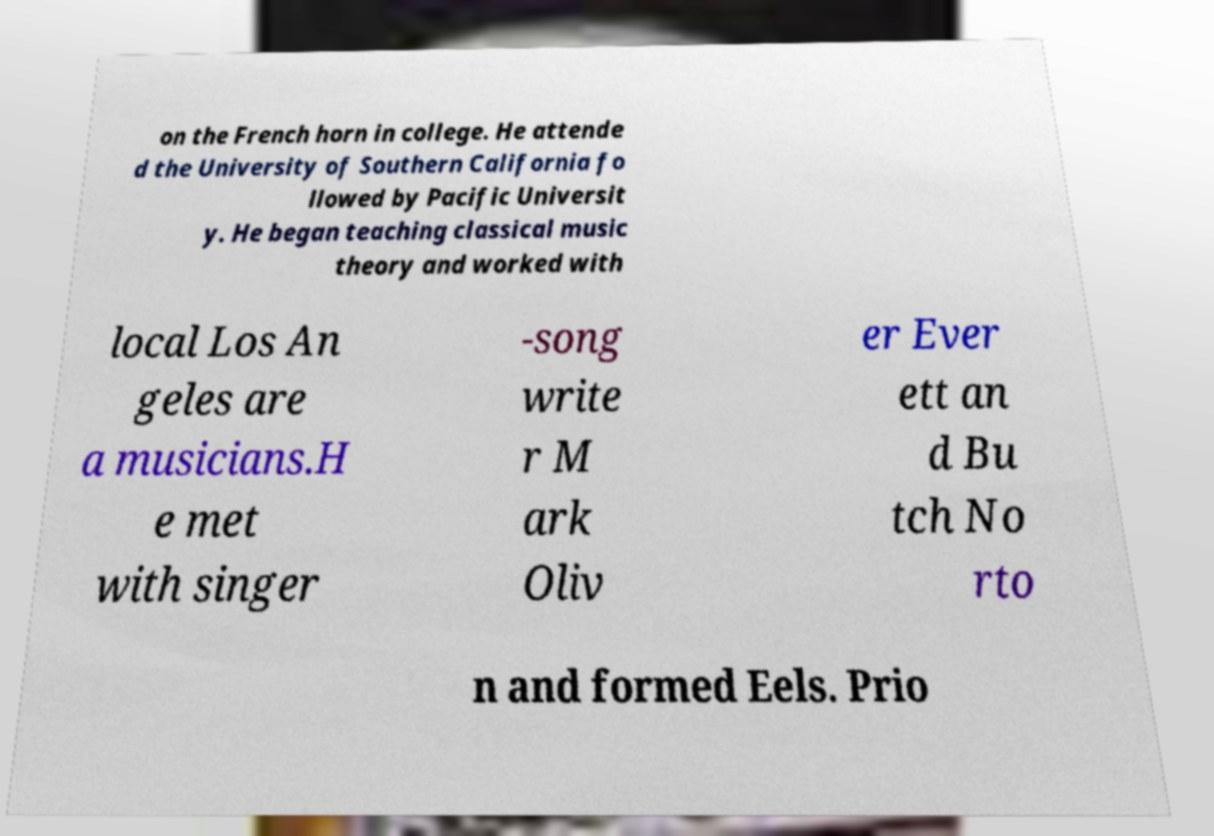Can you accurately transcribe the text from the provided image for me? on the French horn in college. He attende d the University of Southern California fo llowed by Pacific Universit y. He began teaching classical music theory and worked with local Los An geles are a musicians.H e met with singer -song write r M ark Oliv er Ever ett an d Bu tch No rto n and formed Eels. Prio 